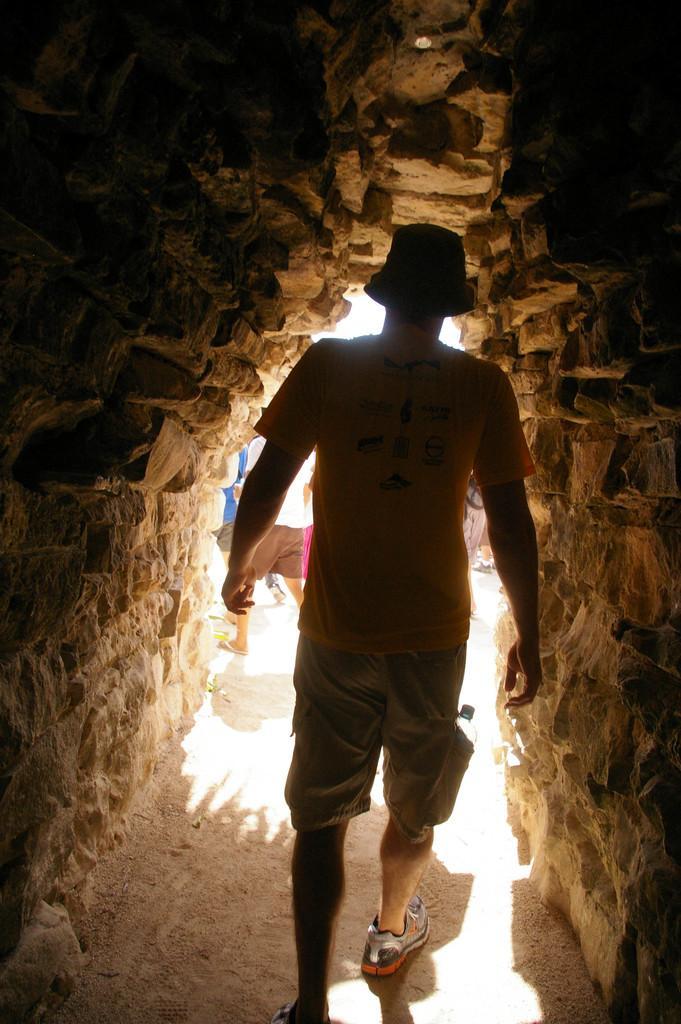In one or two sentences, can you explain what this image depicts? In the foreground of this picture, there is a man walking in cave like structure. In the background, there are persons moving on the ground. 